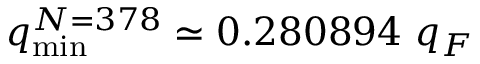<formula> <loc_0><loc_0><loc_500><loc_500>q _ { \min } ^ { N = 3 7 8 } \simeq 0 . 2 8 0 8 9 4 q _ { F }</formula> 